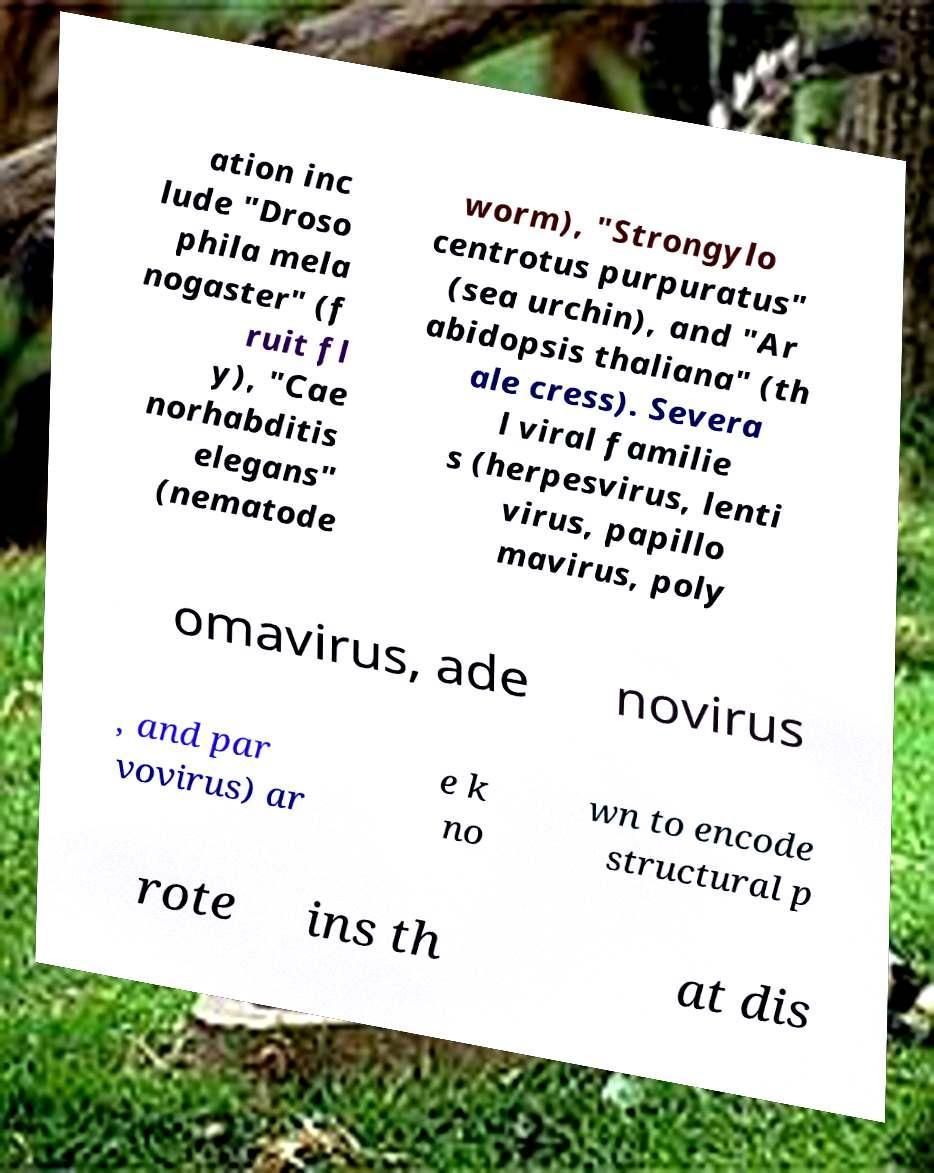I need the written content from this picture converted into text. Can you do that? ation inc lude "Droso phila mela nogaster" (f ruit fl y), "Cae norhabditis elegans" (nematode worm), "Strongylo centrotus purpuratus" (sea urchin), and "Ar abidopsis thaliana" (th ale cress). Severa l viral familie s (herpesvirus, lenti virus, papillo mavirus, poly omavirus, ade novirus , and par vovirus) ar e k no wn to encode structural p rote ins th at dis 